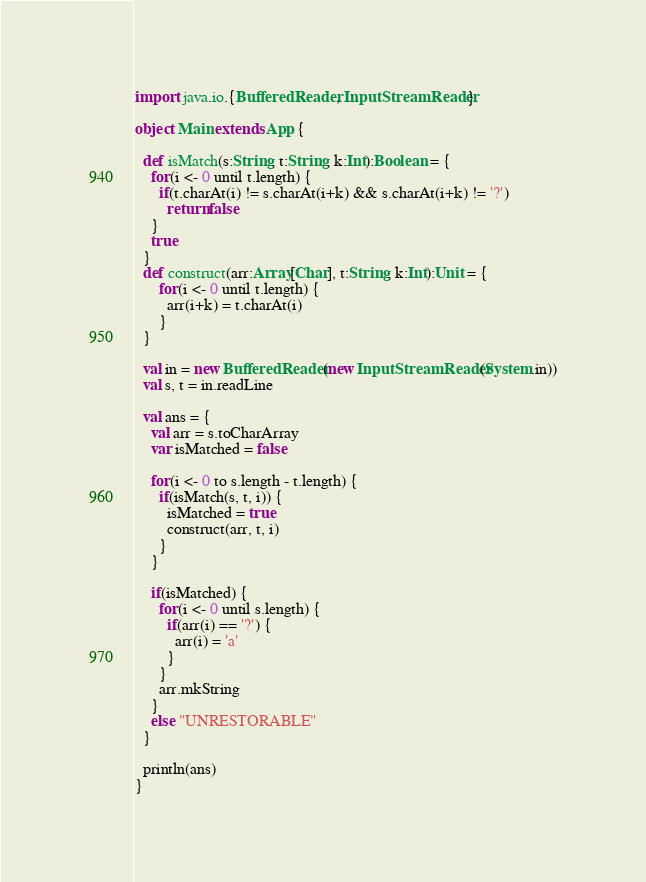Convert code to text. <code><loc_0><loc_0><loc_500><loc_500><_Scala_>import java.io.{BufferedReader, InputStreamReader}

object Main extends App {

  def isMatch(s:String, t:String, k:Int):Boolean = {
    for(i <- 0 until t.length) {
      if(t.charAt(i) != s.charAt(i+k) && s.charAt(i+k) != '?')
        return false
    }
    true
  }
  def construct(arr:Array[Char], t:String, k:Int):Unit = {
      for(i <- 0 until t.length) {
        arr(i+k) = t.charAt(i)
      }
  }

  val in = new BufferedReader(new InputStreamReader(System.in))
  val s, t = in.readLine

  val ans = {
    val arr = s.toCharArray
    var isMatched = false

    for(i <- 0 to s.length - t.length) {
      if(isMatch(s, t, i)) {
        isMatched = true
        construct(arr, t, i)
      }
    }

    if(isMatched) {
      for(i <- 0 until s.length) {
        if(arr(i) == '?') {
          arr(i) = 'a'
        }
      }
      arr.mkString
    }
    else "UNRESTORABLE"
  }

  println(ans)
}</code> 